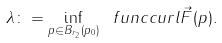Convert formula to latex. <formula><loc_0><loc_0><loc_500><loc_500>\lambda \colon = \inf _ { p \in B _ { r _ { 2 } } ( p _ { 0 } ) } \ f u n c { c u r l } \vec { F } ( p ) .</formula> 